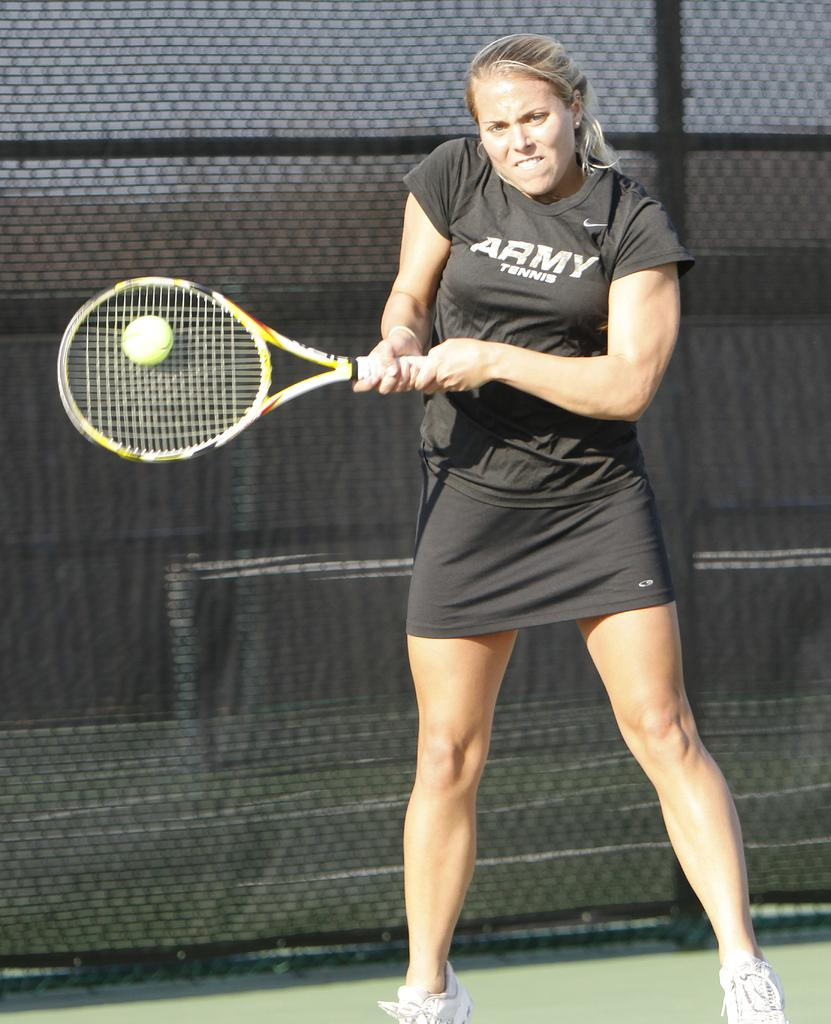Who is the main subject in the image? There is a woman in the image. What is the woman wearing? The woman is wearing a black dress. What activity is the woman engaged in? The woman is playing tennis. What can be seen in the background of the image? There is a green fence in the background of the image. What decision does the woman make in the image? There is no indication of a decision being made in the image; it simply shows the woman playing tennis. 